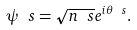Convert formula to latex. <formula><loc_0><loc_0><loc_500><loc_500>\psi _ { \ } s = \sqrt { n _ { \ } s } e ^ { i \theta _ { \ } s } .</formula> 